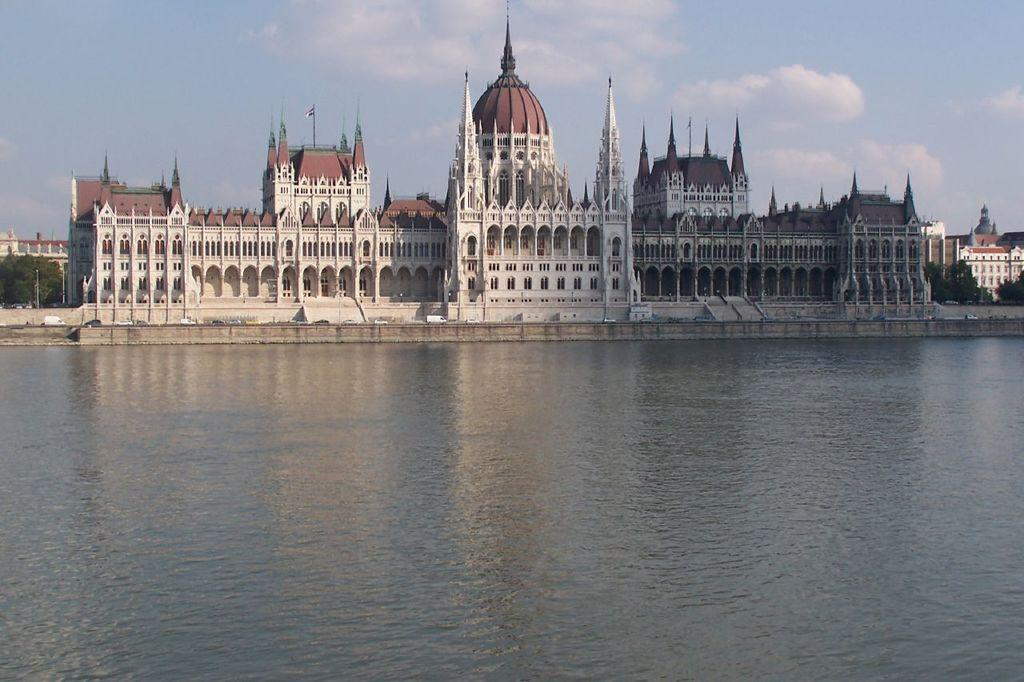What is the main element present in the image? There is water in the image. What structures can be seen near the water? There are buildings near the water. What type of vegetation is present near the water? There are trees near the water. What can be seen in the background of the image? There are clouds and the sky visible in the background. What time of day is it in the image, considering the presence of the afternoon? The provided facts do not mention the time of day or the presence of an afternoon. The image only shows water, buildings, trees, clouds, and the sky. 